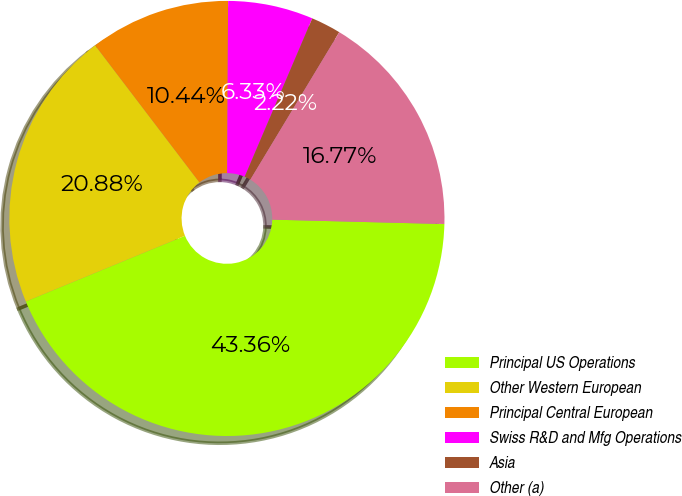<chart> <loc_0><loc_0><loc_500><loc_500><pie_chart><fcel>Principal US Operations<fcel>Other Western European<fcel>Principal Central European<fcel>Swiss R&D and Mfg Operations<fcel>Asia<fcel>Other (a)<nl><fcel>43.36%<fcel>20.88%<fcel>10.44%<fcel>6.33%<fcel>2.22%<fcel>16.77%<nl></chart> 